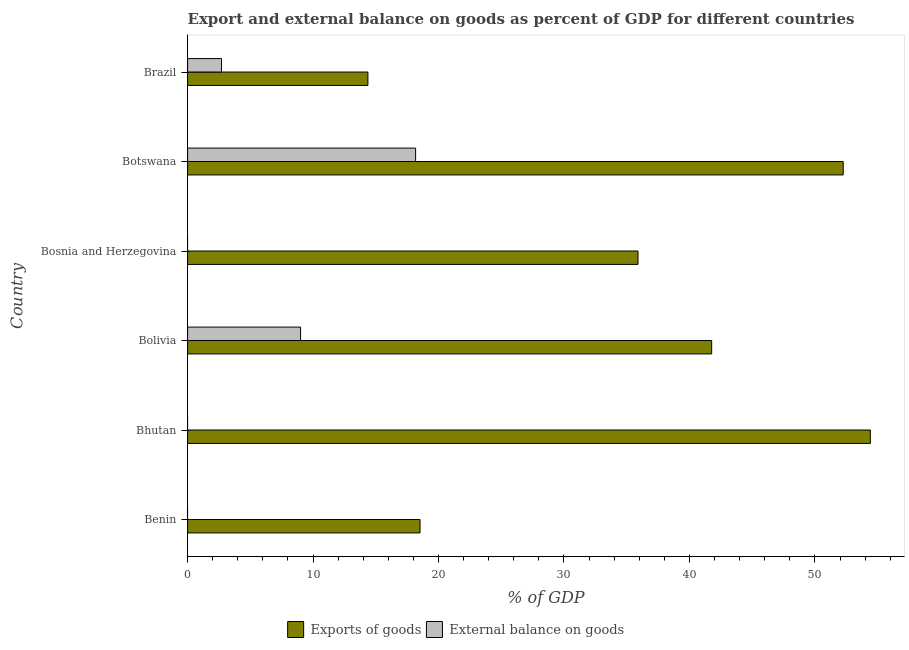Are the number of bars on each tick of the Y-axis equal?
Provide a short and direct response. No. What is the label of the 4th group of bars from the top?
Your answer should be compact. Bolivia. What is the export of goods as percentage of gdp in Bosnia and Herzegovina?
Your response must be concise. 35.9. Across all countries, what is the maximum export of goods as percentage of gdp?
Give a very brief answer. 54.42. In which country was the external balance on goods as percentage of gdp maximum?
Offer a very short reply. Botswana. What is the total external balance on goods as percentage of gdp in the graph?
Your answer should be compact. 29.88. What is the difference between the export of goods as percentage of gdp in Bolivia and that in Botswana?
Give a very brief answer. -10.48. What is the difference between the external balance on goods as percentage of gdp in Brazil and the export of goods as percentage of gdp in Bosnia and Herzegovina?
Your answer should be very brief. -33.2. What is the average external balance on goods as percentage of gdp per country?
Offer a terse response. 4.98. What is the difference between the export of goods as percentage of gdp and external balance on goods as percentage of gdp in Brazil?
Your response must be concise. 11.67. What is the ratio of the export of goods as percentage of gdp in Bhutan to that in Bolivia?
Your answer should be compact. 1.3. Is the export of goods as percentage of gdp in Bolivia less than that in Brazil?
Offer a very short reply. No. What is the difference between the highest and the second highest external balance on goods as percentage of gdp?
Offer a very short reply. 9.17. What is the difference between the highest and the lowest external balance on goods as percentage of gdp?
Give a very brief answer. 18.17. In how many countries, is the external balance on goods as percentage of gdp greater than the average external balance on goods as percentage of gdp taken over all countries?
Give a very brief answer. 2. Is the sum of the export of goods as percentage of gdp in Benin and Bolivia greater than the maximum external balance on goods as percentage of gdp across all countries?
Provide a succinct answer. Yes. Are all the bars in the graph horizontal?
Provide a short and direct response. Yes. How many countries are there in the graph?
Make the answer very short. 6. What is the difference between two consecutive major ticks on the X-axis?
Offer a very short reply. 10. Are the values on the major ticks of X-axis written in scientific E-notation?
Offer a very short reply. No. Does the graph contain any zero values?
Make the answer very short. Yes. How many legend labels are there?
Your answer should be very brief. 2. What is the title of the graph?
Provide a succinct answer. Export and external balance on goods as percent of GDP for different countries. Does "From Government" appear as one of the legend labels in the graph?
Give a very brief answer. No. What is the label or title of the X-axis?
Make the answer very short. % of GDP. What is the label or title of the Y-axis?
Give a very brief answer. Country. What is the % of GDP in Exports of goods in Benin?
Offer a very short reply. 18.53. What is the % of GDP in External balance on goods in Benin?
Provide a succinct answer. 0. What is the % of GDP in Exports of goods in Bhutan?
Your response must be concise. 54.42. What is the % of GDP of Exports of goods in Bolivia?
Your answer should be compact. 41.77. What is the % of GDP in External balance on goods in Bolivia?
Give a very brief answer. 9.01. What is the % of GDP of Exports of goods in Bosnia and Herzegovina?
Make the answer very short. 35.9. What is the % of GDP of External balance on goods in Bosnia and Herzegovina?
Make the answer very short. 0. What is the % of GDP of Exports of goods in Botswana?
Offer a terse response. 52.25. What is the % of GDP in External balance on goods in Botswana?
Keep it short and to the point. 18.17. What is the % of GDP of Exports of goods in Brazil?
Your response must be concise. 14.37. What is the % of GDP in External balance on goods in Brazil?
Provide a succinct answer. 2.7. Across all countries, what is the maximum % of GDP of Exports of goods?
Your response must be concise. 54.42. Across all countries, what is the maximum % of GDP of External balance on goods?
Provide a short and direct response. 18.17. Across all countries, what is the minimum % of GDP of Exports of goods?
Provide a succinct answer. 14.37. What is the total % of GDP in Exports of goods in the graph?
Provide a succinct answer. 217.25. What is the total % of GDP in External balance on goods in the graph?
Make the answer very short. 29.88. What is the difference between the % of GDP in Exports of goods in Benin and that in Bhutan?
Give a very brief answer. -35.89. What is the difference between the % of GDP in Exports of goods in Benin and that in Bolivia?
Your response must be concise. -23.24. What is the difference between the % of GDP in Exports of goods in Benin and that in Bosnia and Herzegovina?
Provide a succinct answer. -17.37. What is the difference between the % of GDP of Exports of goods in Benin and that in Botswana?
Your answer should be very brief. -33.73. What is the difference between the % of GDP in Exports of goods in Benin and that in Brazil?
Make the answer very short. 4.16. What is the difference between the % of GDP of Exports of goods in Bhutan and that in Bolivia?
Your answer should be compact. 12.65. What is the difference between the % of GDP in Exports of goods in Bhutan and that in Bosnia and Herzegovina?
Provide a short and direct response. 18.52. What is the difference between the % of GDP in Exports of goods in Bhutan and that in Botswana?
Give a very brief answer. 2.17. What is the difference between the % of GDP of Exports of goods in Bhutan and that in Brazil?
Your answer should be very brief. 40.05. What is the difference between the % of GDP of Exports of goods in Bolivia and that in Bosnia and Herzegovina?
Provide a succinct answer. 5.87. What is the difference between the % of GDP in Exports of goods in Bolivia and that in Botswana?
Make the answer very short. -10.48. What is the difference between the % of GDP in External balance on goods in Bolivia and that in Botswana?
Provide a succinct answer. -9.17. What is the difference between the % of GDP in Exports of goods in Bolivia and that in Brazil?
Make the answer very short. 27.4. What is the difference between the % of GDP of External balance on goods in Bolivia and that in Brazil?
Provide a succinct answer. 6.3. What is the difference between the % of GDP in Exports of goods in Bosnia and Herzegovina and that in Botswana?
Give a very brief answer. -16.36. What is the difference between the % of GDP in Exports of goods in Bosnia and Herzegovina and that in Brazil?
Offer a terse response. 21.53. What is the difference between the % of GDP in Exports of goods in Botswana and that in Brazil?
Provide a succinct answer. 37.88. What is the difference between the % of GDP of External balance on goods in Botswana and that in Brazil?
Give a very brief answer. 15.47. What is the difference between the % of GDP of Exports of goods in Benin and the % of GDP of External balance on goods in Bolivia?
Your answer should be compact. 9.52. What is the difference between the % of GDP of Exports of goods in Benin and the % of GDP of External balance on goods in Botswana?
Your answer should be compact. 0.35. What is the difference between the % of GDP in Exports of goods in Benin and the % of GDP in External balance on goods in Brazil?
Keep it short and to the point. 15.82. What is the difference between the % of GDP of Exports of goods in Bhutan and the % of GDP of External balance on goods in Bolivia?
Your answer should be compact. 45.41. What is the difference between the % of GDP of Exports of goods in Bhutan and the % of GDP of External balance on goods in Botswana?
Provide a short and direct response. 36.25. What is the difference between the % of GDP in Exports of goods in Bhutan and the % of GDP in External balance on goods in Brazil?
Make the answer very short. 51.72. What is the difference between the % of GDP of Exports of goods in Bolivia and the % of GDP of External balance on goods in Botswana?
Offer a very short reply. 23.6. What is the difference between the % of GDP of Exports of goods in Bolivia and the % of GDP of External balance on goods in Brazil?
Provide a short and direct response. 39.07. What is the difference between the % of GDP in Exports of goods in Bosnia and Herzegovina and the % of GDP in External balance on goods in Botswana?
Ensure brevity in your answer.  17.72. What is the difference between the % of GDP in Exports of goods in Bosnia and Herzegovina and the % of GDP in External balance on goods in Brazil?
Your response must be concise. 33.2. What is the difference between the % of GDP of Exports of goods in Botswana and the % of GDP of External balance on goods in Brazil?
Make the answer very short. 49.55. What is the average % of GDP in Exports of goods per country?
Your answer should be compact. 36.21. What is the average % of GDP of External balance on goods per country?
Ensure brevity in your answer.  4.98. What is the difference between the % of GDP in Exports of goods and % of GDP in External balance on goods in Bolivia?
Keep it short and to the point. 32.77. What is the difference between the % of GDP in Exports of goods and % of GDP in External balance on goods in Botswana?
Offer a very short reply. 34.08. What is the difference between the % of GDP of Exports of goods and % of GDP of External balance on goods in Brazil?
Make the answer very short. 11.67. What is the ratio of the % of GDP of Exports of goods in Benin to that in Bhutan?
Your answer should be compact. 0.34. What is the ratio of the % of GDP in Exports of goods in Benin to that in Bolivia?
Your answer should be compact. 0.44. What is the ratio of the % of GDP of Exports of goods in Benin to that in Bosnia and Herzegovina?
Provide a short and direct response. 0.52. What is the ratio of the % of GDP of Exports of goods in Benin to that in Botswana?
Ensure brevity in your answer.  0.35. What is the ratio of the % of GDP in Exports of goods in Benin to that in Brazil?
Provide a succinct answer. 1.29. What is the ratio of the % of GDP of Exports of goods in Bhutan to that in Bolivia?
Give a very brief answer. 1.3. What is the ratio of the % of GDP of Exports of goods in Bhutan to that in Bosnia and Herzegovina?
Your answer should be compact. 1.52. What is the ratio of the % of GDP of Exports of goods in Bhutan to that in Botswana?
Give a very brief answer. 1.04. What is the ratio of the % of GDP of Exports of goods in Bhutan to that in Brazil?
Offer a terse response. 3.79. What is the ratio of the % of GDP of Exports of goods in Bolivia to that in Bosnia and Herzegovina?
Ensure brevity in your answer.  1.16. What is the ratio of the % of GDP in Exports of goods in Bolivia to that in Botswana?
Your response must be concise. 0.8. What is the ratio of the % of GDP of External balance on goods in Bolivia to that in Botswana?
Provide a short and direct response. 0.5. What is the ratio of the % of GDP in Exports of goods in Bolivia to that in Brazil?
Provide a succinct answer. 2.91. What is the ratio of the % of GDP in External balance on goods in Bolivia to that in Brazil?
Provide a succinct answer. 3.33. What is the ratio of the % of GDP of Exports of goods in Bosnia and Herzegovina to that in Botswana?
Offer a very short reply. 0.69. What is the ratio of the % of GDP in Exports of goods in Bosnia and Herzegovina to that in Brazil?
Provide a short and direct response. 2.5. What is the ratio of the % of GDP in Exports of goods in Botswana to that in Brazil?
Your answer should be very brief. 3.64. What is the ratio of the % of GDP in External balance on goods in Botswana to that in Brazil?
Offer a very short reply. 6.72. What is the difference between the highest and the second highest % of GDP of Exports of goods?
Provide a short and direct response. 2.17. What is the difference between the highest and the second highest % of GDP in External balance on goods?
Offer a terse response. 9.17. What is the difference between the highest and the lowest % of GDP of Exports of goods?
Offer a terse response. 40.05. What is the difference between the highest and the lowest % of GDP in External balance on goods?
Offer a terse response. 18.17. 